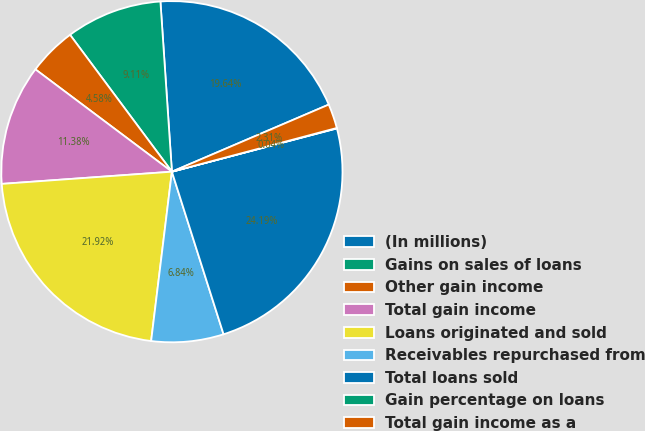<chart> <loc_0><loc_0><loc_500><loc_500><pie_chart><fcel>(In millions)<fcel>Gains on sales of loans<fcel>Other gain income<fcel>Total gain income<fcel>Loans originated and sold<fcel>Receivables repurchased from<fcel>Total loans sold<fcel>Gain percentage on loans<fcel>Total gain income as a<nl><fcel>19.64%<fcel>9.11%<fcel>4.58%<fcel>11.38%<fcel>21.92%<fcel>6.84%<fcel>24.19%<fcel>0.04%<fcel>2.31%<nl></chart> 